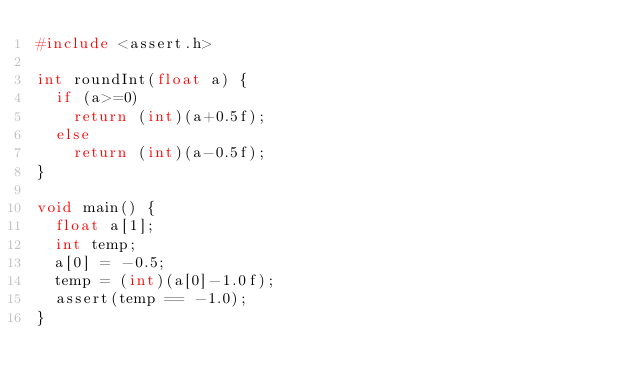Convert code to text. <code><loc_0><loc_0><loc_500><loc_500><_C_>#include <assert.h>

int roundInt(float a) {
  if (a>=0)
    return (int)(a+0.5f);
  else
    return (int)(a-0.5f);
}

void main() {
  float a[1];
	int temp;
	a[0] = -0.5;
	temp = (int)(a[0]-1.0f);
  assert(temp == -1.0);
}

</code> 